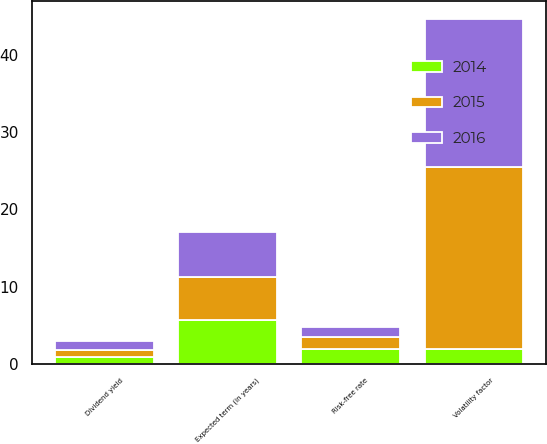Convert chart. <chart><loc_0><loc_0><loc_500><loc_500><stacked_bar_chart><ecel><fcel>Volatility factor<fcel>Dividend yield<fcel>Expected term (in years)<fcel>Risk-free rate<nl><fcel>2016<fcel>19.2<fcel>1.1<fcel>5.78<fcel>1.3<nl><fcel>2015<fcel>23.6<fcel>0.9<fcel>5.66<fcel>1.6<nl><fcel>2014<fcel>1.9<fcel>0.9<fcel>5.65<fcel>1.9<nl></chart> 